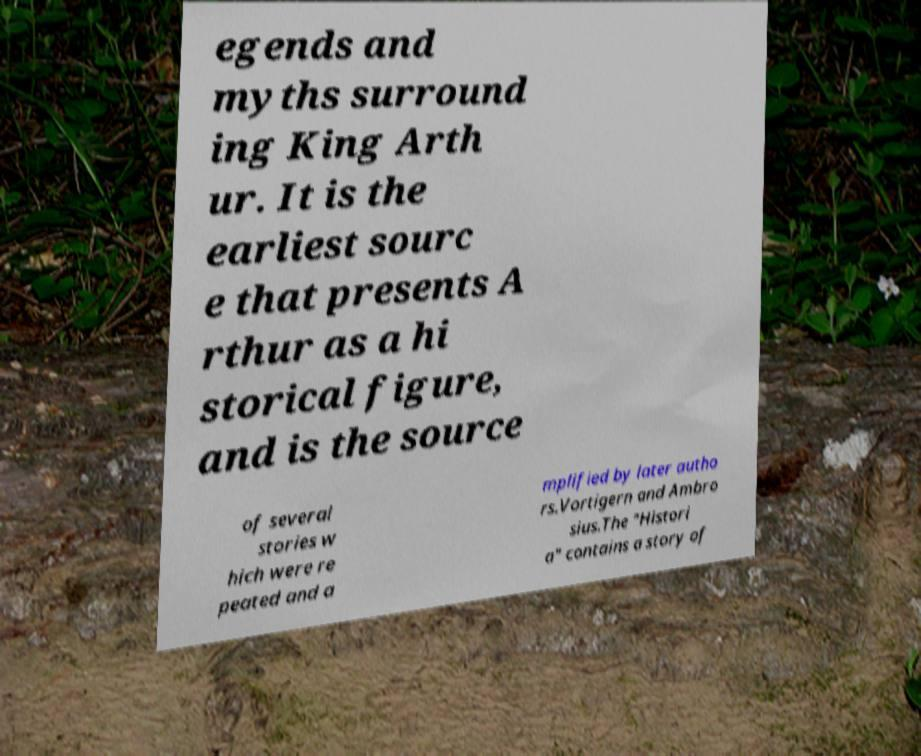Could you assist in decoding the text presented in this image and type it out clearly? egends and myths surround ing King Arth ur. It is the earliest sourc e that presents A rthur as a hi storical figure, and is the source of several stories w hich were re peated and a mplified by later autho rs.Vortigern and Ambro sius.The "Histori a" contains a story of 